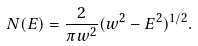Convert formula to latex. <formula><loc_0><loc_0><loc_500><loc_500>N ( E ) = \frac { 2 } { \pi w ^ { 2 } } ( w ^ { 2 } - E ^ { 2 } ) ^ { 1 / 2 } .</formula> 